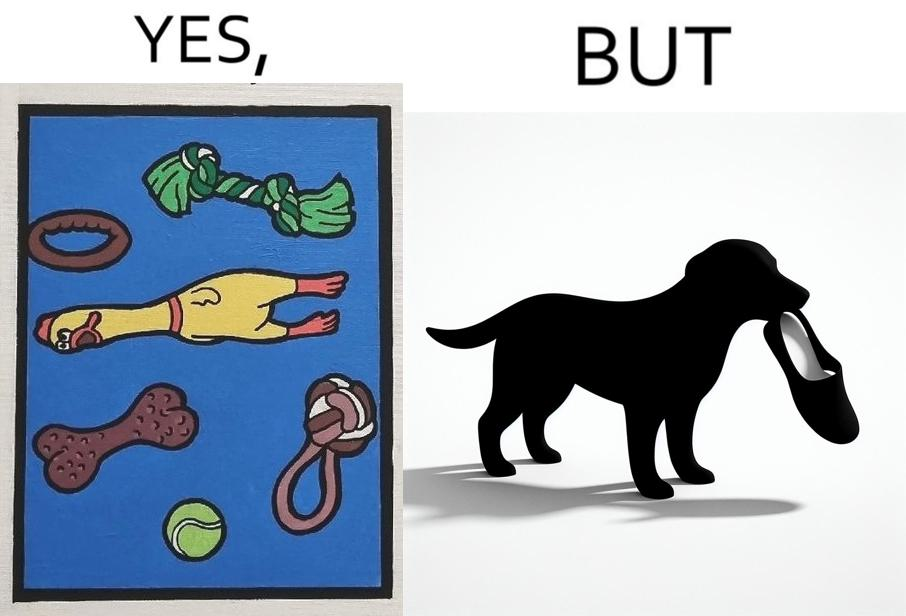Describe what you see in this image. the irony is that dog owners buy loads of toys for their dog but the dog's favourite toy is the owner's slippers 